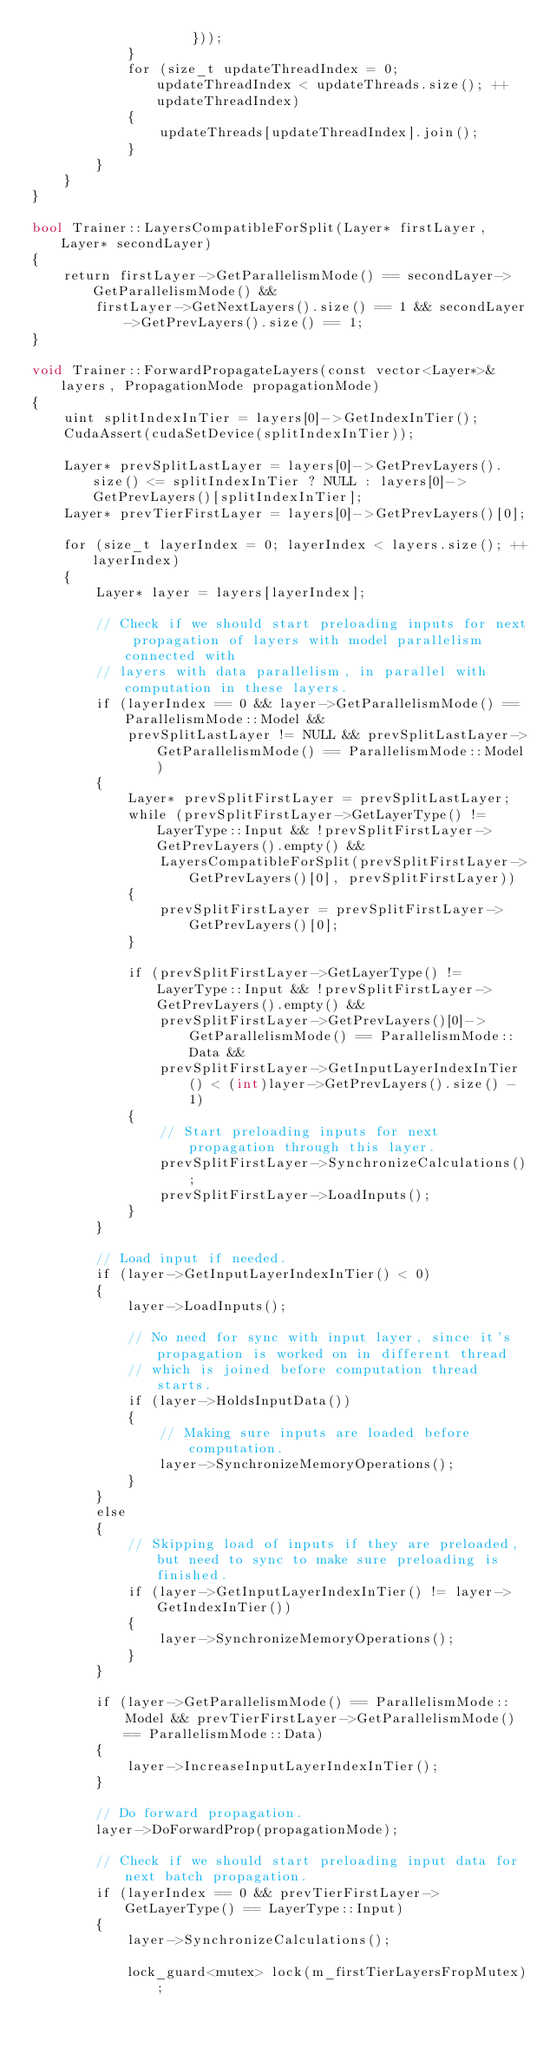<code> <loc_0><loc_0><loc_500><loc_500><_Cuda_>                    }));
            }
            for (size_t updateThreadIndex = 0; updateThreadIndex < updateThreads.size(); ++updateThreadIndex)
            {
                updateThreads[updateThreadIndex].join();
            }
        }
    }
}

bool Trainer::LayersCompatibleForSplit(Layer* firstLayer, Layer* secondLayer)
{
    return firstLayer->GetParallelismMode() == secondLayer->GetParallelismMode() &&
        firstLayer->GetNextLayers().size() == 1 && secondLayer->GetPrevLayers().size() == 1;
}

void Trainer::ForwardPropagateLayers(const vector<Layer*>& layers, PropagationMode propagationMode)
{
    uint splitIndexInTier = layers[0]->GetIndexInTier();
    CudaAssert(cudaSetDevice(splitIndexInTier));

    Layer* prevSplitLastLayer = layers[0]->GetPrevLayers().size() <= splitIndexInTier ? NULL : layers[0]->GetPrevLayers()[splitIndexInTier];
    Layer* prevTierFirstLayer = layers[0]->GetPrevLayers()[0];

    for (size_t layerIndex = 0; layerIndex < layers.size(); ++layerIndex)
    {
        Layer* layer = layers[layerIndex];

        // Check if we should start preloading inputs for next propagation of layers with model parallelism connected with
        // layers with data parallelism, in parallel with computation in these layers.
        if (layerIndex == 0 && layer->GetParallelismMode() == ParallelismMode::Model &&
            prevSplitLastLayer != NULL && prevSplitLastLayer->GetParallelismMode() == ParallelismMode::Model)
        {
            Layer* prevSplitFirstLayer = prevSplitLastLayer;
            while (prevSplitFirstLayer->GetLayerType() != LayerType::Input && !prevSplitFirstLayer->GetPrevLayers().empty() &&
                LayersCompatibleForSplit(prevSplitFirstLayer->GetPrevLayers()[0], prevSplitFirstLayer))
            {
                prevSplitFirstLayer = prevSplitFirstLayer->GetPrevLayers()[0];
            }

            if (prevSplitFirstLayer->GetLayerType() != LayerType::Input && !prevSplitFirstLayer->GetPrevLayers().empty() &&
                prevSplitFirstLayer->GetPrevLayers()[0]->GetParallelismMode() == ParallelismMode::Data &&
                prevSplitFirstLayer->GetInputLayerIndexInTier() < (int)layer->GetPrevLayers().size() - 1)
            {
                // Start preloading inputs for next propagation through this layer.
                prevSplitFirstLayer->SynchronizeCalculations();
                prevSplitFirstLayer->LoadInputs();
            }
        }

        // Load input if needed.
        if (layer->GetInputLayerIndexInTier() < 0)
        {
            layer->LoadInputs();

            // No need for sync with input layer, since it's propagation is worked on in different thread
            // which is joined before computation thread starts.
            if (layer->HoldsInputData())
            {
                // Making sure inputs are loaded before computation.
                layer->SynchronizeMemoryOperations();
            }
        }
        else
        {
            // Skipping load of inputs if they are preloaded, but need to sync to make sure preloading is finished.
            if (layer->GetInputLayerIndexInTier() != layer->GetIndexInTier())
            {
                layer->SynchronizeMemoryOperations();
            }
        }

        if (layer->GetParallelismMode() == ParallelismMode::Model && prevTierFirstLayer->GetParallelismMode() == ParallelismMode::Data)
        {
            layer->IncreaseInputLayerIndexInTier();
        }

        // Do forward propagation.
        layer->DoForwardProp(propagationMode);

        // Check if we should start preloading input data for next batch propagation.
        if (layerIndex == 0 && prevTierFirstLayer->GetLayerType() == LayerType::Input)
        {
            layer->SynchronizeCalculations();

            lock_guard<mutex> lock(m_firstTierLayersFropMutex);</code> 